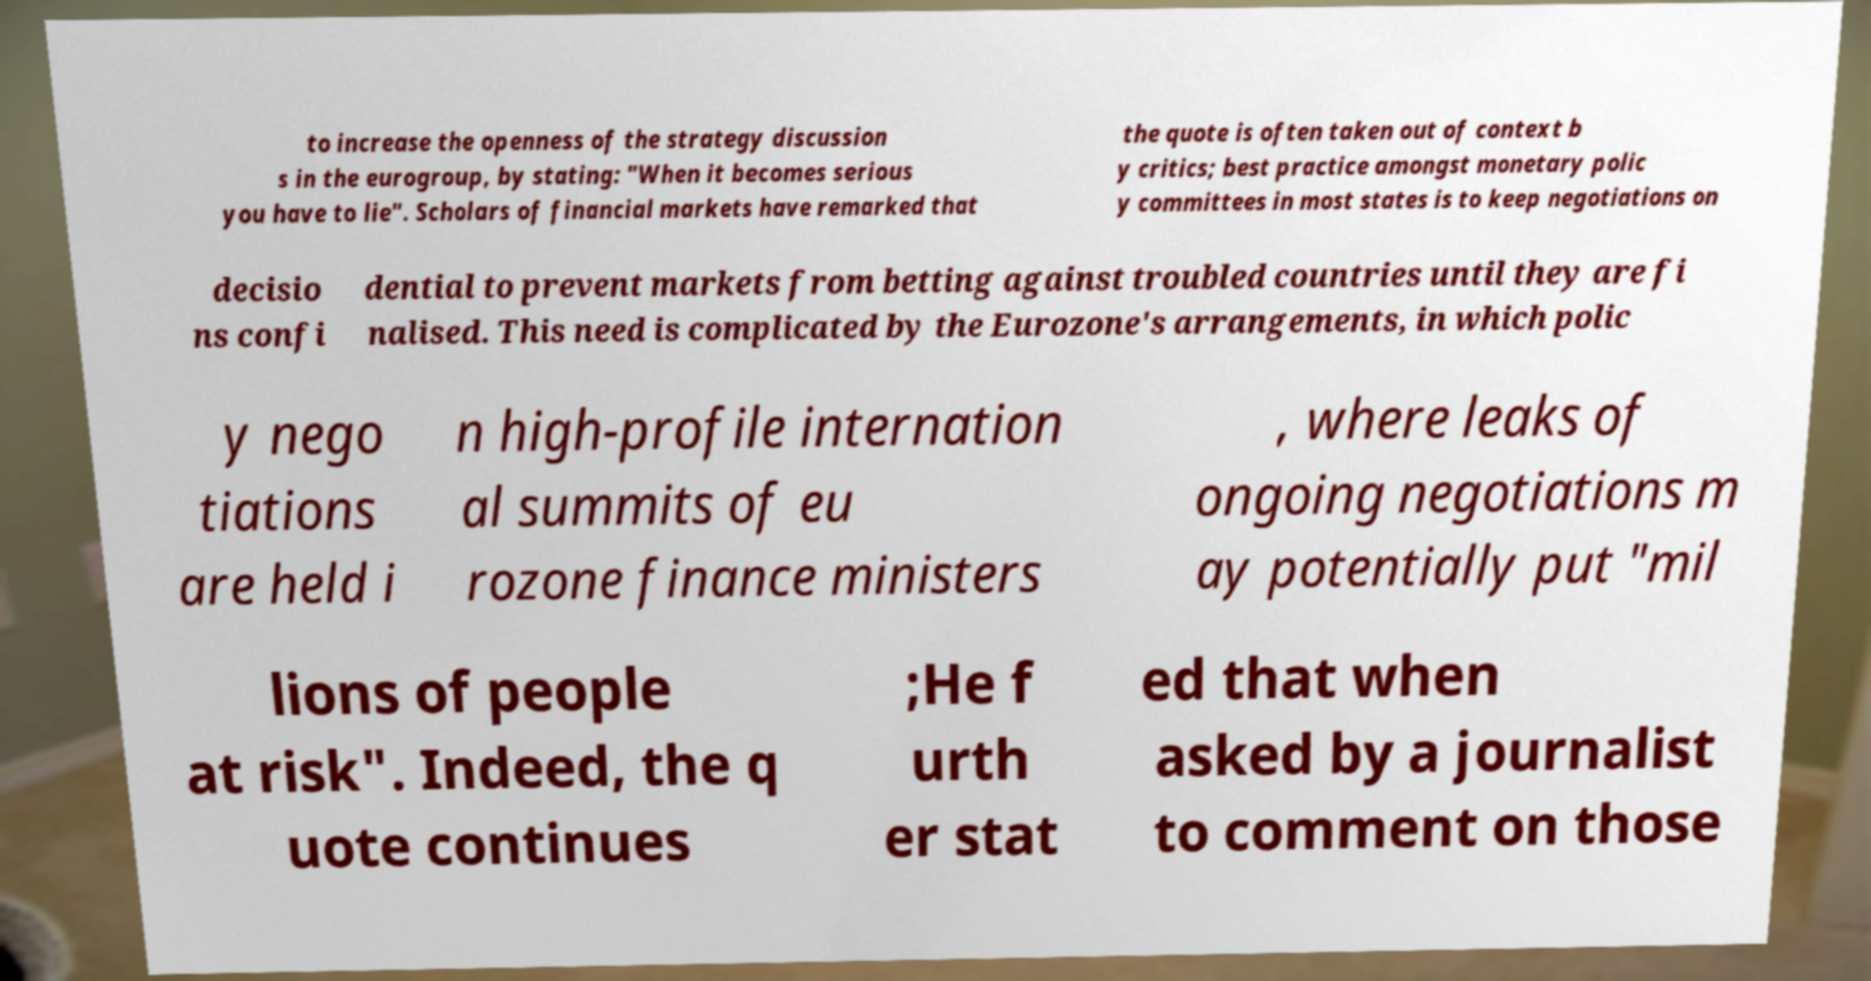I need the written content from this picture converted into text. Can you do that? to increase the openness of the strategy discussion s in the eurogroup, by stating: "When it becomes serious you have to lie". Scholars of financial markets have remarked that the quote is often taken out of context b y critics; best practice amongst monetary polic y committees in most states is to keep negotiations on decisio ns confi dential to prevent markets from betting against troubled countries until they are fi nalised. This need is complicated by the Eurozone's arrangements, in which polic y nego tiations are held i n high-profile internation al summits of eu rozone finance ministers , where leaks of ongoing negotiations m ay potentially put "mil lions of people at risk". Indeed, the q uote continues ;He f urth er stat ed that when asked by a journalist to comment on those 